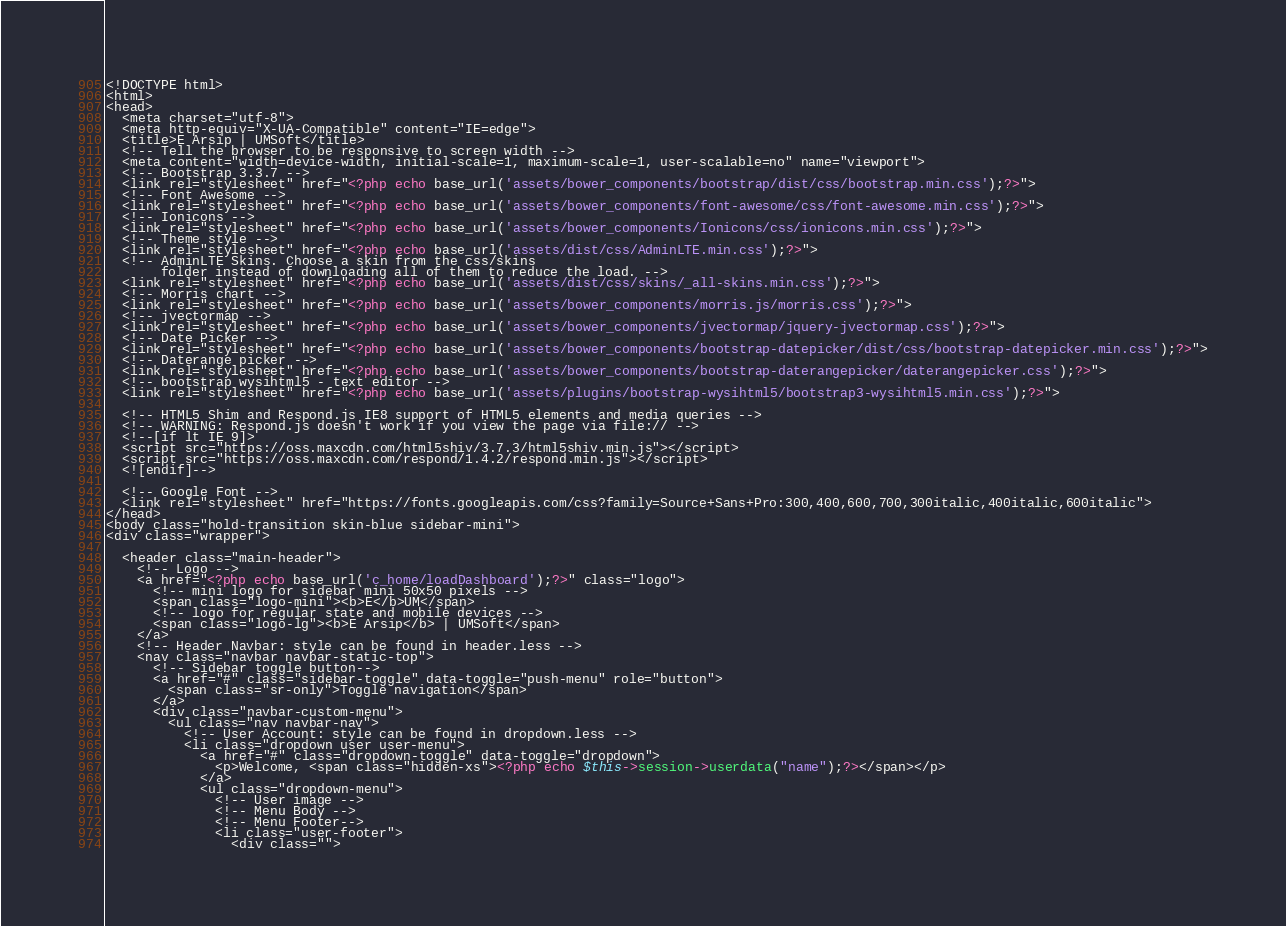Convert code to text. <code><loc_0><loc_0><loc_500><loc_500><_PHP_><!DOCTYPE html>
<html>
<head>
  <meta charset="utf-8">
  <meta http-equiv="X-UA-Compatible" content="IE=edge">
  <title>E Arsip | UMSoft</title>
  <!-- Tell the browser to be responsive to screen width -->
  <meta content="width=device-width, initial-scale=1, maximum-scale=1, user-scalable=no" name="viewport">
  <!-- Bootstrap 3.3.7 -->
  <link rel="stylesheet" href="<?php echo base_url('assets/bower_components/bootstrap/dist/css/bootstrap.min.css');?>">
  <!-- Font Awesome -->
  <link rel="stylesheet" href="<?php echo base_url('assets/bower_components/font-awesome/css/font-awesome.min.css');?>">
  <!-- Ionicons -->
  <link rel="stylesheet" href="<?php echo base_url('assets/bower_components/Ionicons/css/ionicons.min.css');?>">
  <!-- Theme style -->
  <link rel="stylesheet" href="<?php echo base_url('assets/dist/css/AdminLTE.min.css');?>">
  <!-- AdminLTE Skins. Choose a skin from the css/skins
       folder instead of downloading all of them to reduce the load. -->
  <link rel="stylesheet" href="<?php echo base_url('assets/dist/css/skins/_all-skins.min.css');?>">
  <!-- Morris chart -->
  <link rel="stylesheet" href="<?php echo base_url('assets/bower_components/morris.js/morris.css');?>">
  <!-- jvectormap -->
  <link rel="stylesheet" href="<?php echo base_url('assets/bower_components/jvectormap/jquery-jvectormap.css');?>">
  <!-- Date Picker -->
  <link rel="stylesheet" href="<?php echo base_url('assets/bower_components/bootstrap-datepicker/dist/css/bootstrap-datepicker.min.css');?>">
  <!-- Daterange picker -->
  <link rel="stylesheet" href="<?php echo base_url('assets/bower_components/bootstrap-daterangepicker/daterangepicker.css');?>">
  <!-- bootstrap wysihtml5 - text editor -->
  <link rel="stylesheet" href="<?php echo base_url('assets/plugins/bootstrap-wysihtml5/bootstrap3-wysihtml5.min.css');?>">

  <!-- HTML5 Shim and Respond.js IE8 support of HTML5 elements and media queries -->
  <!-- WARNING: Respond.js doesn't work if you view the page via file:// -->
  <!--[if lt IE 9]>
  <script src="https://oss.maxcdn.com/html5shiv/3.7.3/html5shiv.min.js"></script>
  <script src="https://oss.maxcdn.com/respond/1.4.2/respond.min.js"></script>
  <![endif]-->

  <!-- Google Font -->
  <link rel="stylesheet" href="https://fonts.googleapis.com/css?family=Source+Sans+Pro:300,400,600,700,300italic,400italic,600italic">
</head>
<body class="hold-transition skin-blue sidebar-mini">
<div class="wrapper">

  <header class="main-header">
    <!-- Logo -->
    <a href="<?php echo base_url('c_home/loadDashboard');?>" class="logo">
      <!-- mini logo for sidebar mini 50x50 pixels -->
      <span class="logo-mini"><b>E</b>UM</span>
      <!-- logo for regular state and mobile devices -->
      <span class="logo-lg"><b>E Arsip</b> | UMSoft</span>
    </a>
    <!-- Header Navbar: style can be found in header.less -->
    <nav class="navbar navbar-static-top">
      <!-- Sidebar toggle button-->
      <a href="#" class="sidebar-toggle" data-toggle="push-menu" role="button">
        <span class="sr-only">Toggle navigation</span>
      </a>
      <div class="navbar-custom-menu">
        <ul class="nav navbar-nav">
          <!-- User Account: style can be found in dropdown.less -->
          <li class="dropdown user user-menu">
            <a href="#" class="dropdown-toggle" data-toggle="dropdown">
              <p>Welcome, <span class="hidden-xs"><?php echo $this->session->userdata("name");?></span></p>
            </a>
            <ul class="dropdown-menu">
              <!-- User image -->
              <!-- Menu Body -->
              <!-- Menu Footer-->
              <li class="user-footer">
                <div class=""></code> 